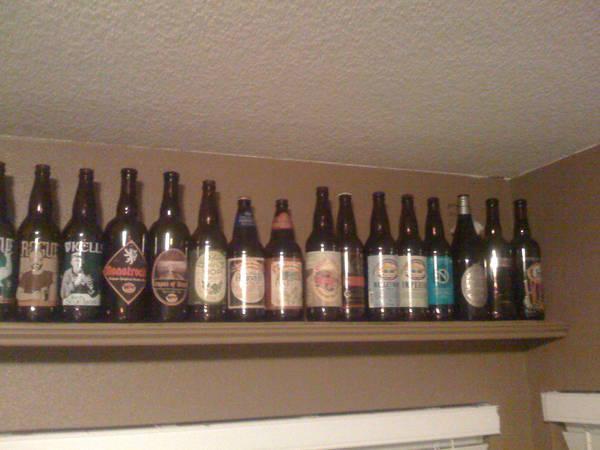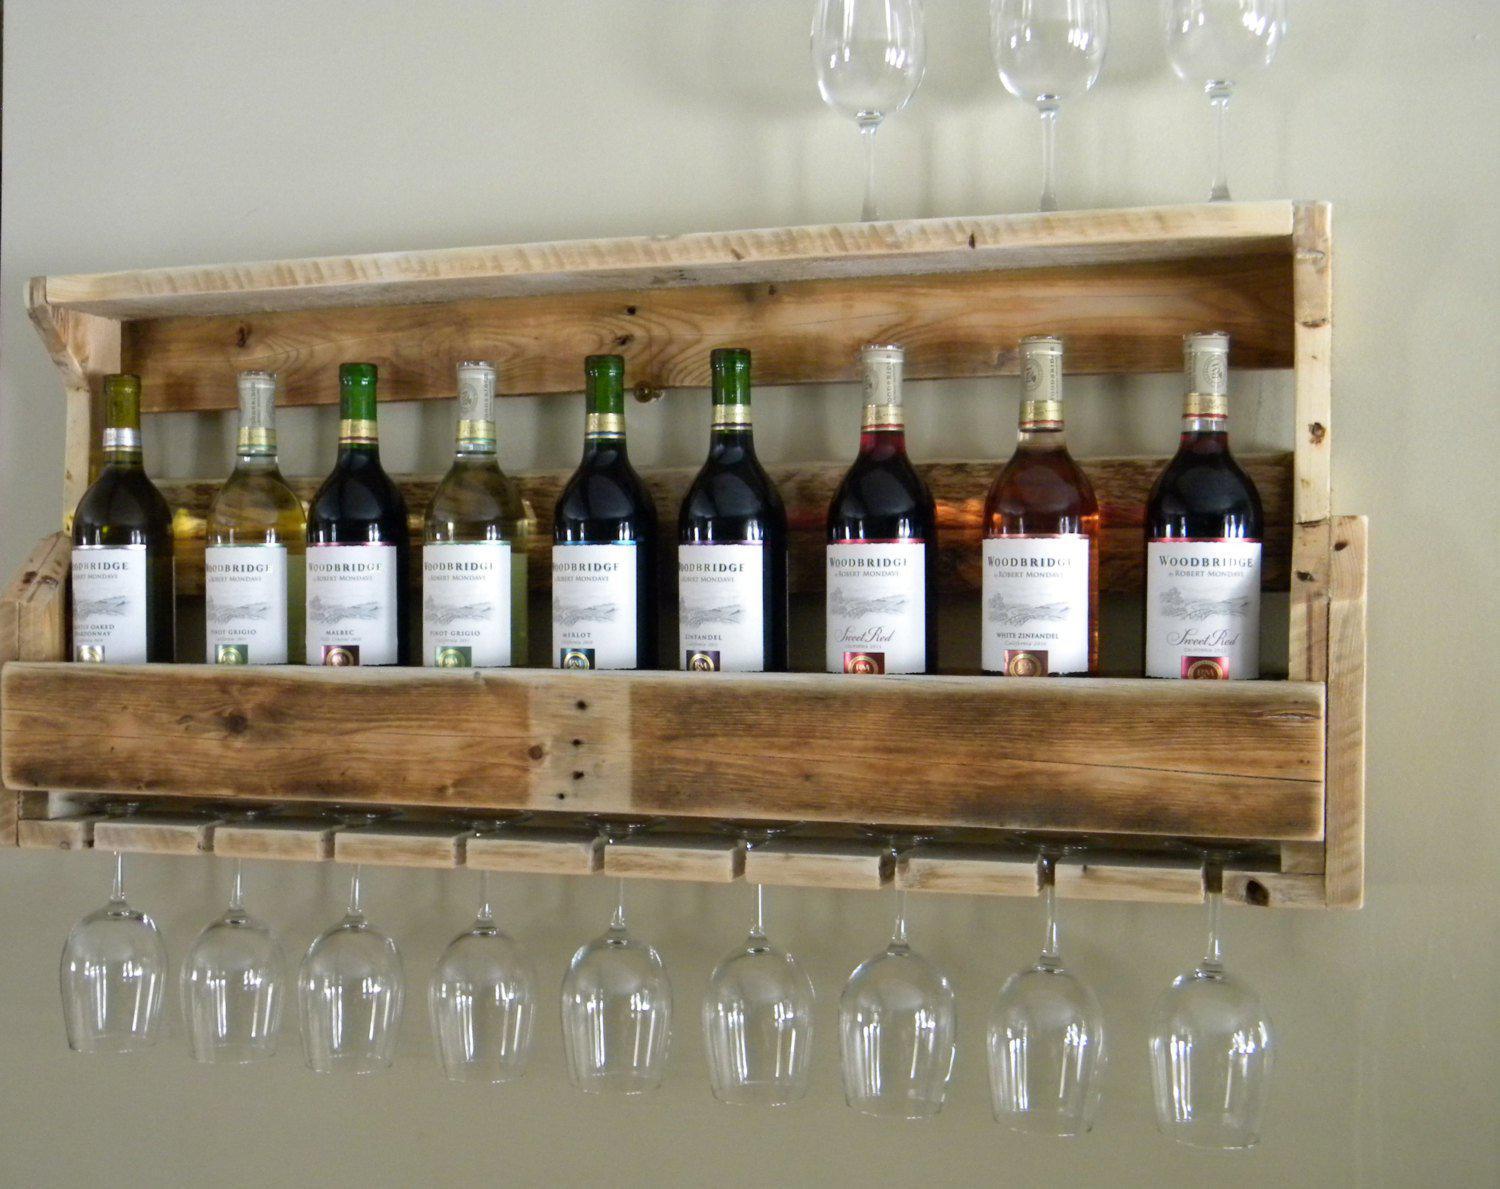The first image is the image on the left, the second image is the image on the right. Given the left and right images, does the statement "An image shows only one shelf with at least 13 bottles lined in a row." hold true? Answer yes or no. Yes. 